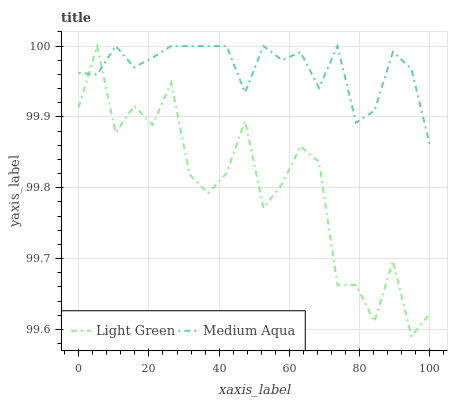Does Light Green have the minimum area under the curve?
Answer yes or no. Yes. Does Medium Aqua have the maximum area under the curve?
Answer yes or no. Yes. Does Light Green have the maximum area under the curve?
Answer yes or no. No. Is Medium Aqua the smoothest?
Answer yes or no. Yes. Is Light Green the roughest?
Answer yes or no. Yes. Is Light Green the smoothest?
Answer yes or no. No. Does Light Green have the highest value?
Answer yes or no. Yes. Does Medium Aqua intersect Light Green?
Answer yes or no. Yes. Is Medium Aqua less than Light Green?
Answer yes or no. No. Is Medium Aqua greater than Light Green?
Answer yes or no. No. 